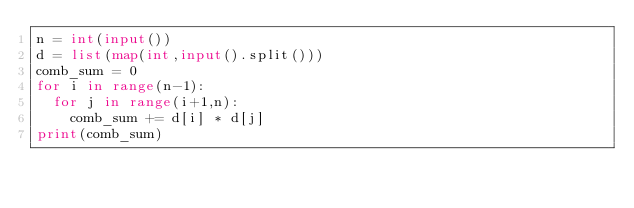<code> <loc_0><loc_0><loc_500><loc_500><_Python_>n = int(input())
d = list(map(int,input().split()))
comb_sum = 0
for i in range(n-1):
  for j in range(i+1,n):
    comb_sum += d[i] * d[j]
print(comb_sum)</code> 